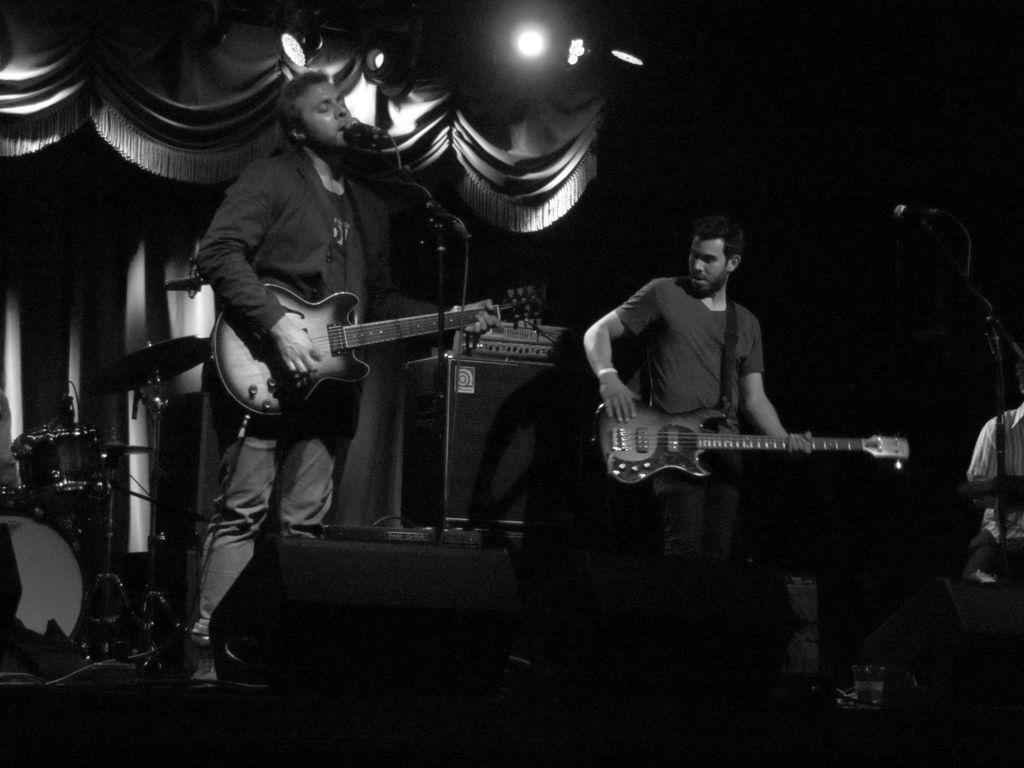Please provide a concise description of this image. 2 people are standing playing guitar. in front of them there is a microphone. behind them there are drums at the left. and at the back there are curtains and lights. 